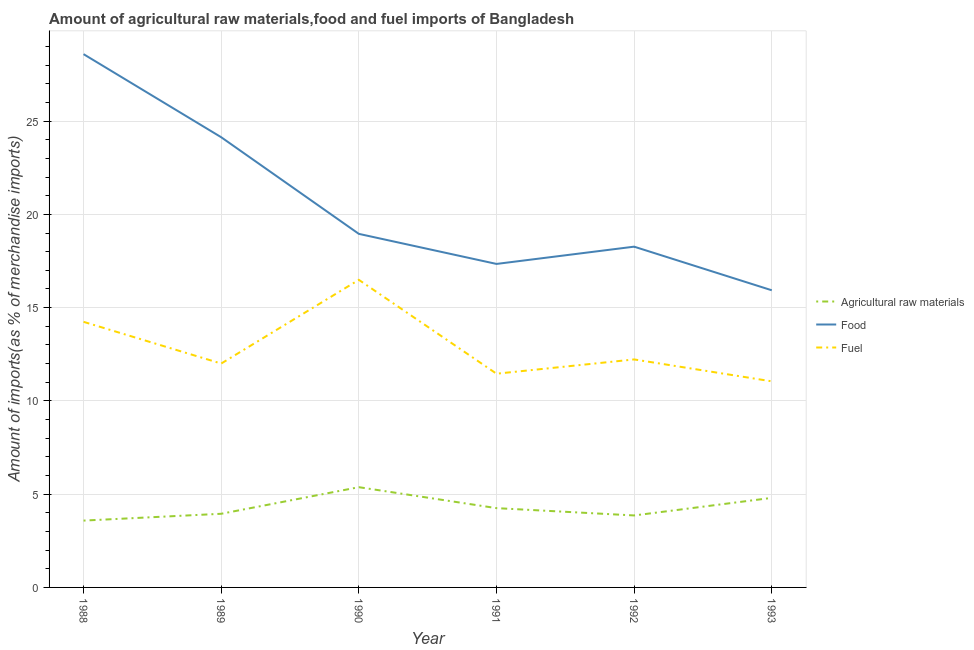How many different coloured lines are there?
Provide a succinct answer. 3. Does the line corresponding to percentage of fuel imports intersect with the line corresponding to percentage of raw materials imports?
Offer a terse response. No. Is the number of lines equal to the number of legend labels?
Keep it short and to the point. Yes. What is the percentage of fuel imports in 1990?
Keep it short and to the point. 16.49. Across all years, what is the maximum percentage of food imports?
Ensure brevity in your answer.  28.59. Across all years, what is the minimum percentage of raw materials imports?
Give a very brief answer. 3.58. In which year was the percentage of food imports maximum?
Ensure brevity in your answer.  1988. What is the total percentage of raw materials imports in the graph?
Offer a terse response. 25.82. What is the difference between the percentage of food imports in 1990 and that in 1993?
Make the answer very short. 3.02. What is the difference between the percentage of fuel imports in 1988 and the percentage of raw materials imports in 1993?
Give a very brief answer. 9.44. What is the average percentage of raw materials imports per year?
Keep it short and to the point. 4.3. In the year 1988, what is the difference between the percentage of raw materials imports and percentage of fuel imports?
Give a very brief answer. -10.66. In how many years, is the percentage of raw materials imports greater than 5 %?
Offer a terse response. 1. What is the ratio of the percentage of food imports in 1991 to that in 1992?
Offer a terse response. 0.95. Is the percentage of raw materials imports in 1988 less than that in 1991?
Give a very brief answer. Yes. Is the difference between the percentage of fuel imports in 1988 and 1991 greater than the difference between the percentage of food imports in 1988 and 1991?
Ensure brevity in your answer.  No. What is the difference between the highest and the second highest percentage of food imports?
Provide a succinct answer. 4.45. What is the difference between the highest and the lowest percentage of fuel imports?
Make the answer very short. 5.44. In how many years, is the percentage of raw materials imports greater than the average percentage of raw materials imports taken over all years?
Your answer should be compact. 2. Is the sum of the percentage of fuel imports in 1992 and 1993 greater than the maximum percentage of raw materials imports across all years?
Keep it short and to the point. Yes. Is it the case that in every year, the sum of the percentage of raw materials imports and percentage of food imports is greater than the percentage of fuel imports?
Your answer should be very brief. Yes. Does the percentage of fuel imports monotonically increase over the years?
Your answer should be very brief. No. Is the percentage of food imports strictly greater than the percentage of raw materials imports over the years?
Keep it short and to the point. Yes. Is the percentage of raw materials imports strictly less than the percentage of food imports over the years?
Your response must be concise. Yes. What is the difference between two consecutive major ticks on the Y-axis?
Offer a terse response. 5. Does the graph contain any zero values?
Keep it short and to the point. No. What is the title of the graph?
Ensure brevity in your answer.  Amount of agricultural raw materials,food and fuel imports of Bangladesh. What is the label or title of the Y-axis?
Keep it short and to the point. Amount of imports(as % of merchandise imports). What is the Amount of imports(as % of merchandise imports) in Agricultural raw materials in 1988?
Provide a succinct answer. 3.58. What is the Amount of imports(as % of merchandise imports) in Food in 1988?
Your answer should be compact. 28.59. What is the Amount of imports(as % of merchandise imports) in Fuel in 1988?
Offer a very short reply. 14.24. What is the Amount of imports(as % of merchandise imports) in Agricultural raw materials in 1989?
Make the answer very short. 3.95. What is the Amount of imports(as % of merchandise imports) of Food in 1989?
Your response must be concise. 24.14. What is the Amount of imports(as % of merchandise imports) in Fuel in 1989?
Your answer should be very brief. 12. What is the Amount of imports(as % of merchandise imports) of Agricultural raw materials in 1990?
Provide a short and direct response. 5.37. What is the Amount of imports(as % of merchandise imports) of Food in 1990?
Your answer should be compact. 18.95. What is the Amount of imports(as % of merchandise imports) of Fuel in 1990?
Give a very brief answer. 16.49. What is the Amount of imports(as % of merchandise imports) of Agricultural raw materials in 1991?
Your answer should be very brief. 4.25. What is the Amount of imports(as % of merchandise imports) in Food in 1991?
Your answer should be compact. 17.34. What is the Amount of imports(as % of merchandise imports) in Fuel in 1991?
Provide a short and direct response. 11.46. What is the Amount of imports(as % of merchandise imports) in Agricultural raw materials in 1992?
Provide a short and direct response. 3.86. What is the Amount of imports(as % of merchandise imports) of Food in 1992?
Offer a terse response. 18.27. What is the Amount of imports(as % of merchandise imports) in Fuel in 1992?
Make the answer very short. 12.22. What is the Amount of imports(as % of merchandise imports) in Agricultural raw materials in 1993?
Your response must be concise. 4.8. What is the Amount of imports(as % of merchandise imports) of Food in 1993?
Your answer should be very brief. 15.93. What is the Amount of imports(as % of merchandise imports) of Fuel in 1993?
Make the answer very short. 11.05. Across all years, what is the maximum Amount of imports(as % of merchandise imports) in Agricultural raw materials?
Give a very brief answer. 5.37. Across all years, what is the maximum Amount of imports(as % of merchandise imports) in Food?
Offer a terse response. 28.59. Across all years, what is the maximum Amount of imports(as % of merchandise imports) of Fuel?
Provide a succinct answer. 16.49. Across all years, what is the minimum Amount of imports(as % of merchandise imports) of Agricultural raw materials?
Your answer should be very brief. 3.58. Across all years, what is the minimum Amount of imports(as % of merchandise imports) in Food?
Offer a very short reply. 15.93. Across all years, what is the minimum Amount of imports(as % of merchandise imports) of Fuel?
Provide a short and direct response. 11.05. What is the total Amount of imports(as % of merchandise imports) in Agricultural raw materials in the graph?
Provide a short and direct response. 25.82. What is the total Amount of imports(as % of merchandise imports) of Food in the graph?
Provide a succinct answer. 123.22. What is the total Amount of imports(as % of merchandise imports) of Fuel in the graph?
Provide a succinct answer. 77.46. What is the difference between the Amount of imports(as % of merchandise imports) in Agricultural raw materials in 1988 and that in 1989?
Give a very brief answer. -0.37. What is the difference between the Amount of imports(as % of merchandise imports) of Food in 1988 and that in 1989?
Provide a succinct answer. 4.45. What is the difference between the Amount of imports(as % of merchandise imports) in Fuel in 1988 and that in 1989?
Provide a short and direct response. 2.24. What is the difference between the Amount of imports(as % of merchandise imports) of Agricultural raw materials in 1988 and that in 1990?
Make the answer very short. -1.79. What is the difference between the Amount of imports(as % of merchandise imports) of Food in 1988 and that in 1990?
Your response must be concise. 9.64. What is the difference between the Amount of imports(as % of merchandise imports) in Fuel in 1988 and that in 1990?
Provide a succinct answer. -2.25. What is the difference between the Amount of imports(as % of merchandise imports) in Agricultural raw materials in 1988 and that in 1991?
Ensure brevity in your answer.  -0.67. What is the difference between the Amount of imports(as % of merchandise imports) in Food in 1988 and that in 1991?
Offer a very short reply. 11.25. What is the difference between the Amount of imports(as % of merchandise imports) of Fuel in 1988 and that in 1991?
Give a very brief answer. 2.78. What is the difference between the Amount of imports(as % of merchandise imports) in Agricultural raw materials in 1988 and that in 1992?
Your response must be concise. -0.28. What is the difference between the Amount of imports(as % of merchandise imports) in Food in 1988 and that in 1992?
Your answer should be very brief. 10.32. What is the difference between the Amount of imports(as % of merchandise imports) of Fuel in 1988 and that in 1992?
Provide a succinct answer. 2.02. What is the difference between the Amount of imports(as % of merchandise imports) in Agricultural raw materials in 1988 and that in 1993?
Offer a terse response. -1.22. What is the difference between the Amount of imports(as % of merchandise imports) in Food in 1988 and that in 1993?
Ensure brevity in your answer.  12.66. What is the difference between the Amount of imports(as % of merchandise imports) in Fuel in 1988 and that in 1993?
Provide a short and direct response. 3.19. What is the difference between the Amount of imports(as % of merchandise imports) in Agricultural raw materials in 1989 and that in 1990?
Keep it short and to the point. -1.43. What is the difference between the Amount of imports(as % of merchandise imports) in Food in 1989 and that in 1990?
Keep it short and to the point. 5.18. What is the difference between the Amount of imports(as % of merchandise imports) in Fuel in 1989 and that in 1990?
Offer a terse response. -4.49. What is the difference between the Amount of imports(as % of merchandise imports) of Agricultural raw materials in 1989 and that in 1991?
Make the answer very short. -0.3. What is the difference between the Amount of imports(as % of merchandise imports) in Food in 1989 and that in 1991?
Your answer should be very brief. 6.79. What is the difference between the Amount of imports(as % of merchandise imports) of Fuel in 1989 and that in 1991?
Your answer should be very brief. 0.54. What is the difference between the Amount of imports(as % of merchandise imports) of Agricultural raw materials in 1989 and that in 1992?
Your answer should be compact. 0.09. What is the difference between the Amount of imports(as % of merchandise imports) of Food in 1989 and that in 1992?
Make the answer very short. 5.87. What is the difference between the Amount of imports(as % of merchandise imports) of Fuel in 1989 and that in 1992?
Provide a short and direct response. -0.22. What is the difference between the Amount of imports(as % of merchandise imports) in Agricultural raw materials in 1989 and that in 1993?
Keep it short and to the point. -0.85. What is the difference between the Amount of imports(as % of merchandise imports) of Food in 1989 and that in 1993?
Provide a succinct answer. 8.21. What is the difference between the Amount of imports(as % of merchandise imports) in Fuel in 1989 and that in 1993?
Keep it short and to the point. 0.95. What is the difference between the Amount of imports(as % of merchandise imports) of Agricultural raw materials in 1990 and that in 1991?
Offer a very short reply. 1.12. What is the difference between the Amount of imports(as % of merchandise imports) in Food in 1990 and that in 1991?
Provide a succinct answer. 1.61. What is the difference between the Amount of imports(as % of merchandise imports) of Fuel in 1990 and that in 1991?
Your response must be concise. 5.03. What is the difference between the Amount of imports(as % of merchandise imports) in Agricultural raw materials in 1990 and that in 1992?
Your answer should be compact. 1.52. What is the difference between the Amount of imports(as % of merchandise imports) in Food in 1990 and that in 1992?
Offer a very short reply. 0.69. What is the difference between the Amount of imports(as % of merchandise imports) of Fuel in 1990 and that in 1992?
Your answer should be compact. 4.27. What is the difference between the Amount of imports(as % of merchandise imports) of Agricultural raw materials in 1990 and that in 1993?
Provide a succinct answer. 0.57. What is the difference between the Amount of imports(as % of merchandise imports) of Food in 1990 and that in 1993?
Give a very brief answer. 3.02. What is the difference between the Amount of imports(as % of merchandise imports) in Fuel in 1990 and that in 1993?
Offer a terse response. 5.44. What is the difference between the Amount of imports(as % of merchandise imports) in Agricultural raw materials in 1991 and that in 1992?
Offer a terse response. 0.39. What is the difference between the Amount of imports(as % of merchandise imports) of Food in 1991 and that in 1992?
Provide a short and direct response. -0.93. What is the difference between the Amount of imports(as % of merchandise imports) of Fuel in 1991 and that in 1992?
Offer a terse response. -0.77. What is the difference between the Amount of imports(as % of merchandise imports) in Agricultural raw materials in 1991 and that in 1993?
Your response must be concise. -0.55. What is the difference between the Amount of imports(as % of merchandise imports) of Food in 1991 and that in 1993?
Offer a very short reply. 1.41. What is the difference between the Amount of imports(as % of merchandise imports) in Fuel in 1991 and that in 1993?
Keep it short and to the point. 0.41. What is the difference between the Amount of imports(as % of merchandise imports) in Agricultural raw materials in 1992 and that in 1993?
Make the answer very short. -0.94. What is the difference between the Amount of imports(as % of merchandise imports) of Food in 1992 and that in 1993?
Offer a very short reply. 2.34. What is the difference between the Amount of imports(as % of merchandise imports) in Fuel in 1992 and that in 1993?
Provide a short and direct response. 1.17. What is the difference between the Amount of imports(as % of merchandise imports) of Agricultural raw materials in 1988 and the Amount of imports(as % of merchandise imports) of Food in 1989?
Your answer should be compact. -20.55. What is the difference between the Amount of imports(as % of merchandise imports) in Agricultural raw materials in 1988 and the Amount of imports(as % of merchandise imports) in Fuel in 1989?
Make the answer very short. -8.42. What is the difference between the Amount of imports(as % of merchandise imports) of Food in 1988 and the Amount of imports(as % of merchandise imports) of Fuel in 1989?
Keep it short and to the point. 16.59. What is the difference between the Amount of imports(as % of merchandise imports) in Agricultural raw materials in 1988 and the Amount of imports(as % of merchandise imports) in Food in 1990?
Provide a short and direct response. -15.37. What is the difference between the Amount of imports(as % of merchandise imports) of Agricultural raw materials in 1988 and the Amount of imports(as % of merchandise imports) of Fuel in 1990?
Your answer should be very brief. -12.91. What is the difference between the Amount of imports(as % of merchandise imports) of Food in 1988 and the Amount of imports(as % of merchandise imports) of Fuel in 1990?
Your response must be concise. 12.1. What is the difference between the Amount of imports(as % of merchandise imports) of Agricultural raw materials in 1988 and the Amount of imports(as % of merchandise imports) of Food in 1991?
Keep it short and to the point. -13.76. What is the difference between the Amount of imports(as % of merchandise imports) of Agricultural raw materials in 1988 and the Amount of imports(as % of merchandise imports) of Fuel in 1991?
Provide a short and direct response. -7.88. What is the difference between the Amount of imports(as % of merchandise imports) in Food in 1988 and the Amount of imports(as % of merchandise imports) in Fuel in 1991?
Your response must be concise. 17.13. What is the difference between the Amount of imports(as % of merchandise imports) in Agricultural raw materials in 1988 and the Amount of imports(as % of merchandise imports) in Food in 1992?
Ensure brevity in your answer.  -14.69. What is the difference between the Amount of imports(as % of merchandise imports) in Agricultural raw materials in 1988 and the Amount of imports(as % of merchandise imports) in Fuel in 1992?
Ensure brevity in your answer.  -8.64. What is the difference between the Amount of imports(as % of merchandise imports) in Food in 1988 and the Amount of imports(as % of merchandise imports) in Fuel in 1992?
Provide a succinct answer. 16.37. What is the difference between the Amount of imports(as % of merchandise imports) of Agricultural raw materials in 1988 and the Amount of imports(as % of merchandise imports) of Food in 1993?
Offer a terse response. -12.35. What is the difference between the Amount of imports(as % of merchandise imports) of Agricultural raw materials in 1988 and the Amount of imports(as % of merchandise imports) of Fuel in 1993?
Offer a very short reply. -7.47. What is the difference between the Amount of imports(as % of merchandise imports) in Food in 1988 and the Amount of imports(as % of merchandise imports) in Fuel in 1993?
Make the answer very short. 17.54. What is the difference between the Amount of imports(as % of merchandise imports) in Agricultural raw materials in 1989 and the Amount of imports(as % of merchandise imports) in Food in 1990?
Give a very brief answer. -15.01. What is the difference between the Amount of imports(as % of merchandise imports) of Agricultural raw materials in 1989 and the Amount of imports(as % of merchandise imports) of Fuel in 1990?
Provide a succinct answer. -12.54. What is the difference between the Amount of imports(as % of merchandise imports) in Food in 1989 and the Amount of imports(as % of merchandise imports) in Fuel in 1990?
Your response must be concise. 7.65. What is the difference between the Amount of imports(as % of merchandise imports) of Agricultural raw materials in 1989 and the Amount of imports(as % of merchandise imports) of Food in 1991?
Keep it short and to the point. -13.39. What is the difference between the Amount of imports(as % of merchandise imports) of Agricultural raw materials in 1989 and the Amount of imports(as % of merchandise imports) of Fuel in 1991?
Provide a short and direct response. -7.51. What is the difference between the Amount of imports(as % of merchandise imports) of Food in 1989 and the Amount of imports(as % of merchandise imports) of Fuel in 1991?
Give a very brief answer. 12.68. What is the difference between the Amount of imports(as % of merchandise imports) of Agricultural raw materials in 1989 and the Amount of imports(as % of merchandise imports) of Food in 1992?
Make the answer very short. -14.32. What is the difference between the Amount of imports(as % of merchandise imports) in Agricultural raw materials in 1989 and the Amount of imports(as % of merchandise imports) in Fuel in 1992?
Keep it short and to the point. -8.27. What is the difference between the Amount of imports(as % of merchandise imports) in Food in 1989 and the Amount of imports(as % of merchandise imports) in Fuel in 1992?
Ensure brevity in your answer.  11.91. What is the difference between the Amount of imports(as % of merchandise imports) of Agricultural raw materials in 1989 and the Amount of imports(as % of merchandise imports) of Food in 1993?
Ensure brevity in your answer.  -11.98. What is the difference between the Amount of imports(as % of merchandise imports) in Agricultural raw materials in 1989 and the Amount of imports(as % of merchandise imports) in Fuel in 1993?
Offer a terse response. -7.1. What is the difference between the Amount of imports(as % of merchandise imports) of Food in 1989 and the Amount of imports(as % of merchandise imports) of Fuel in 1993?
Make the answer very short. 13.09. What is the difference between the Amount of imports(as % of merchandise imports) in Agricultural raw materials in 1990 and the Amount of imports(as % of merchandise imports) in Food in 1991?
Your response must be concise. -11.97. What is the difference between the Amount of imports(as % of merchandise imports) of Agricultural raw materials in 1990 and the Amount of imports(as % of merchandise imports) of Fuel in 1991?
Your answer should be compact. -6.08. What is the difference between the Amount of imports(as % of merchandise imports) of Food in 1990 and the Amount of imports(as % of merchandise imports) of Fuel in 1991?
Provide a succinct answer. 7.5. What is the difference between the Amount of imports(as % of merchandise imports) in Agricultural raw materials in 1990 and the Amount of imports(as % of merchandise imports) in Food in 1992?
Your answer should be very brief. -12.89. What is the difference between the Amount of imports(as % of merchandise imports) in Agricultural raw materials in 1990 and the Amount of imports(as % of merchandise imports) in Fuel in 1992?
Give a very brief answer. -6.85. What is the difference between the Amount of imports(as % of merchandise imports) in Food in 1990 and the Amount of imports(as % of merchandise imports) in Fuel in 1992?
Provide a short and direct response. 6.73. What is the difference between the Amount of imports(as % of merchandise imports) in Agricultural raw materials in 1990 and the Amount of imports(as % of merchandise imports) in Food in 1993?
Offer a terse response. -10.56. What is the difference between the Amount of imports(as % of merchandise imports) of Agricultural raw materials in 1990 and the Amount of imports(as % of merchandise imports) of Fuel in 1993?
Keep it short and to the point. -5.67. What is the difference between the Amount of imports(as % of merchandise imports) of Food in 1990 and the Amount of imports(as % of merchandise imports) of Fuel in 1993?
Offer a terse response. 7.91. What is the difference between the Amount of imports(as % of merchandise imports) in Agricultural raw materials in 1991 and the Amount of imports(as % of merchandise imports) in Food in 1992?
Provide a succinct answer. -14.02. What is the difference between the Amount of imports(as % of merchandise imports) in Agricultural raw materials in 1991 and the Amount of imports(as % of merchandise imports) in Fuel in 1992?
Provide a succinct answer. -7.97. What is the difference between the Amount of imports(as % of merchandise imports) of Food in 1991 and the Amount of imports(as % of merchandise imports) of Fuel in 1992?
Provide a succinct answer. 5.12. What is the difference between the Amount of imports(as % of merchandise imports) of Agricultural raw materials in 1991 and the Amount of imports(as % of merchandise imports) of Food in 1993?
Offer a terse response. -11.68. What is the difference between the Amount of imports(as % of merchandise imports) of Agricultural raw materials in 1991 and the Amount of imports(as % of merchandise imports) of Fuel in 1993?
Offer a very short reply. -6.8. What is the difference between the Amount of imports(as % of merchandise imports) in Food in 1991 and the Amount of imports(as % of merchandise imports) in Fuel in 1993?
Provide a succinct answer. 6.29. What is the difference between the Amount of imports(as % of merchandise imports) in Agricultural raw materials in 1992 and the Amount of imports(as % of merchandise imports) in Food in 1993?
Give a very brief answer. -12.07. What is the difference between the Amount of imports(as % of merchandise imports) of Agricultural raw materials in 1992 and the Amount of imports(as % of merchandise imports) of Fuel in 1993?
Keep it short and to the point. -7.19. What is the difference between the Amount of imports(as % of merchandise imports) in Food in 1992 and the Amount of imports(as % of merchandise imports) in Fuel in 1993?
Make the answer very short. 7.22. What is the average Amount of imports(as % of merchandise imports) of Agricultural raw materials per year?
Make the answer very short. 4.3. What is the average Amount of imports(as % of merchandise imports) of Food per year?
Your answer should be very brief. 20.54. What is the average Amount of imports(as % of merchandise imports) in Fuel per year?
Provide a short and direct response. 12.91. In the year 1988, what is the difference between the Amount of imports(as % of merchandise imports) in Agricultural raw materials and Amount of imports(as % of merchandise imports) in Food?
Your response must be concise. -25.01. In the year 1988, what is the difference between the Amount of imports(as % of merchandise imports) in Agricultural raw materials and Amount of imports(as % of merchandise imports) in Fuel?
Provide a short and direct response. -10.66. In the year 1988, what is the difference between the Amount of imports(as % of merchandise imports) of Food and Amount of imports(as % of merchandise imports) of Fuel?
Your answer should be compact. 14.35. In the year 1989, what is the difference between the Amount of imports(as % of merchandise imports) of Agricultural raw materials and Amount of imports(as % of merchandise imports) of Food?
Keep it short and to the point. -20.19. In the year 1989, what is the difference between the Amount of imports(as % of merchandise imports) of Agricultural raw materials and Amount of imports(as % of merchandise imports) of Fuel?
Provide a short and direct response. -8.05. In the year 1989, what is the difference between the Amount of imports(as % of merchandise imports) in Food and Amount of imports(as % of merchandise imports) in Fuel?
Make the answer very short. 12.13. In the year 1990, what is the difference between the Amount of imports(as % of merchandise imports) in Agricultural raw materials and Amount of imports(as % of merchandise imports) in Food?
Keep it short and to the point. -13.58. In the year 1990, what is the difference between the Amount of imports(as % of merchandise imports) in Agricultural raw materials and Amount of imports(as % of merchandise imports) in Fuel?
Your answer should be compact. -11.12. In the year 1990, what is the difference between the Amount of imports(as % of merchandise imports) in Food and Amount of imports(as % of merchandise imports) in Fuel?
Your answer should be very brief. 2.46. In the year 1991, what is the difference between the Amount of imports(as % of merchandise imports) of Agricultural raw materials and Amount of imports(as % of merchandise imports) of Food?
Offer a terse response. -13.09. In the year 1991, what is the difference between the Amount of imports(as % of merchandise imports) in Agricultural raw materials and Amount of imports(as % of merchandise imports) in Fuel?
Provide a short and direct response. -7.21. In the year 1991, what is the difference between the Amount of imports(as % of merchandise imports) of Food and Amount of imports(as % of merchandise imports) of Fuel?
Ensure brevity in your answer.  5.88. In the year 1992, what is the difference between the Amount of imports(as % of merchandise imports) of Agricultural raw materials and Amount of imports(as % of merchandise imports) of Food?
Offer a very short reply. -14.41. In the year 1992, what is the difference between the Amount of imports(as % of merchandise imports) in Agricultural raw materials and Amount of imports(as % of merchandise imports) in Fuel?
Provide a succinct answer. -8.36. In the year 1992, what is the difference between the Amount of imports(as % of merchandise imports) of Food and Amount of imports(as % of merchandise imports) of Fuel?
Keep it short and to the point. 6.05. In the year 1993, what is the difference between the Amount of imports(as % of merchandise imports) of Agricultural raw materials and Amount of imports(as % of merchandise imports) of Food?
Give a very brief answer. -11.13. In the year 1993, what is the difference between the Amount of imports(as % of merchandise imports) of Agricultural raw materials and Amount of imports(as % of merchandise imports) of Fuel?
Provide a succinct answer. -6.25. In the year 1993, what is the difference between the Amount of imports(as % of merchandise imports) in Food and Amount of imports(as % of merchandise imports) in Fuel?
Offer a very short reply. 4.88. What is the ratio of the Amount of imports(as % of merchandise imports) in Agricultural raw materials in 1988 to that in 1989?
Provide a short and direct response. 0.91. What is the ratio of the Amount of imports(as % of merchandise imports) in Food in 1988 to that in 1989?
Make the answer very short. 1.18. What is the ratio of the Amount of imports(as % of merchandise imports) in Fuel in 1988 to that in 1989?
Give a very brief answer. 1.19. What is the ratio of the Amount of imports(as % of merchandise imports) in Agricultural raw materials in 1988 to that in 1990?
Ensure brevity in your answer.  0.67. What is the ratio of the Amount of imports(as % of merchandise imports) in Food in 1988 to that in 1990?
Keep it short and to the point. 1.51. What is the ratio of the Amount of imports(as % of merchandise imports) of Fuel in 1988 to that in 1990?
Keep it short and to the point. 0.86. What is the ratio of the Amount of imports(as % of merchandise imports) of Agricultural raw materials in 1988 to that in 1991?
Offer a very short reply. 0.84. What is the ratio of the Amount of imports(as % of merchandise imports) of Food in 1988 to that in 1991?
Provide a short and direct response. 1.65. What is the ratio of the Amount of imports(as % of merchandise imports) in Fuel in 1988 to that in 1991?
Offer a very short reply. 1.24. What is the ratio of the Amount of imports(as % of merchandise imports) of Agricultural raw materials in 1988 to that in 1992?
Offer a terse response. 0.93. What is the ratio of the Amount of imports(as % of merchandise imports) of Food in 1988 to that in 1992?
Your answer should be compact. 1.56. What is the ratio of the Amount of imports(as % of merchandise imports) of Fuel in 1988 to that in 1992?
Your answer should be very brief. 1.16. What is the ratio of the Amount of imports(as % of merchandise imports) of Agricultural raw materials in 1988 to that in 1993?
Provide a succinct answer. 0.75. What is the ratio of the Amount of imports(as % of merchandise imports) in Food in 1988 to that in 1993?
Your answer should be compact. 1.79. What is the ratio of the Amount of imports(as % of merchandise imports) of Fuel in 1988 to that in 1993?
Ensure brevity in your answer.  1.29. What is the ratio of the Amount of imports(as % of merchandise imports) in Agricultural raw materials in 1989 to that in 1990?
Make the answer very short. 0.73. What is the ratio of the Amount of imports(as % of merchandise imports) of Food in 1989 to that in 1990?
Your response must be concise. 1.27. What is the ratio of the Amount of imports(as % of merchandise imports) of Fuel in 1989 to that in 1990?
Make the answer very short. 0.73. What is the ratio of the Amount of imports(as % of merchandise imports) of Agricultural raw materials in 1989 to that in 1991?
Your answer should be very brief. 0.93. What is the ratio of the Amount of imports(as % of merchandise imports) of Food in 1989 to that in 1991?
Give a very brief answer. 1.39. What is the ratio of the Amount of imports(as % of merchandise imports) in Fuel in 1989 to that in 1991?
Make the answer very short. 1.05. What is the ratio of the Amount of imports(as % of merchandise imports) of Agricultural raw materials in 1989 to that in 1992?
Give a very brief answer. 1.02. What is the ratio of the Amount of imports(as % of merchandise imports) in Food in 1989 to that in 1992?
Keep it short and to the point. 1.32. What is the ratio of the Amount of imports(as % of merchandise imports) in Fuel in 1989 to that in 1992?
Provide a short and direct response. 0.98. What is the ratio of the Amount of imports(as % of merchandise imports) in Agricultural raw materials in 1989 to that in 1993?
Your answer should be compact. 0.82. What is the ratio of the Amount of imports(as % of merchandise imports) in Food in 1989 to that in 1993?
Offer a terse response. 1.52. What is the ratio of the Amount of imports(as % of merchandise imports) of Fuel in 1989 to that in 1993?
Your answer should be very brief. 1.09. What is the ratio of the Amount of imports(as % of merchandise imports) in Agricultural raw materials in 1990 to that in 1991?
Ensure brevity in your answer.  1.26. What is the ratio of the Amount of imports(as % of merchandise imports) in Food in 1990 to that in 1991?
Keep it short and to the point. 1.09. What is the ratio of the Amount of imports(as % of merchandise imports) of Fuel in 1990 to that in 1991?
Your answer should be very brief. 1.44. What is the ratio of the Amount of imports(as % of merchandise imports) of Agricultural raw materials in 1990 to that in 1992?
Offer a terse response. 1.39. What is the ratio of the Amount of imports(as % of merchandise imports) in Food in 1990 to that in 1992?
Make the answer very short. 1.04. What is the ratio of the Amount of imports(as % of merchandise imports) of Fuel in 1990 to that in 1992?
Give a very brief answer. 1.35. What is the ratio of the Amount of imports(as % of merchandise imports) of Agricultural raw materials in 1990 to that in 1993?
Make the answer very short. 1.12. What is the ratio of the Amount of imports(as % of merchandise imports) in Food in 1990 to that in 1993?
Make the answer very short. 1.19. What is the ratio of the Amount of imports(as % of merchandise imports) in Fuel in 1990 to that in 1993?
Offer a very short reply. 1.49. What is the ratio of the Amount of imports(as % of merchandise imports) in Agricultural raw materials in 1991 to that in 1992?
Keep it short and to the point. 1.1. What is the ratio of the Amount of imports(as % of merchandise imports) in Food in 1991 to that in 1992?
Keep it short and to the point. 0.95. What is the ratio of the Amount of imports(as % of merchandise imports) of Fuel in 1991 to that in 1992?
Provide a short and direct response. 0.94. What is the ratio of the Amount of imports(as % of merchandise imports) of Agricultural raw materials in 1991 to that in 1993?
Your answer should be very brief. 0.89. What is the ratio of the Amount of imports(as % of merchandise imports) in Food in 1991 to that in 1993?
Offer a very short reply. 1.09. What is the ratio of the Amount of imports(as % of merchandise imports) in Agricultural raw materials in 1992 to that in 1993?
Ensure brevity in your answer.  0.8. What is the ratio of the Amount of imports(as % of merchandise imports) of Food in 1992 to that in 1993?
Ensure brevity in your answer.  1.15. What is the ratio of the Amount of imports(as % of merchandise imports) in Fuel in 1992 to that in 1993?
Provide a short and direct response. 1.11. What is the difference between the highest and the second highest Amount of imports(as % of merchandise imports) of Agricultural raw materials?
Keep it short and to the point. 0.57. What is the difference between the highest and the second highest Amount of imports(as % of merchandise imports) of Food?
Keep it short and to the point. 4.45. What is the difference between the highest and the second highest Amount of imports(as % of merchandise imports) of Fuel?
Provide a succinct answer. 2.25. What is the difference between the highest and the lowest Amount of imports(as % of merchandise imports) of Agricultural raw materials?
Your response must be concise. 1.79. What is the difference between the highest and the lowest Amount of imports(as % of merchandise imports) in Food?
Your answer should be compact. 12.66. What is the difference between the highest and the lowest Amount of imports(as % of merchandise imports) in Fuel?
Offer a terse response. 5.44. 